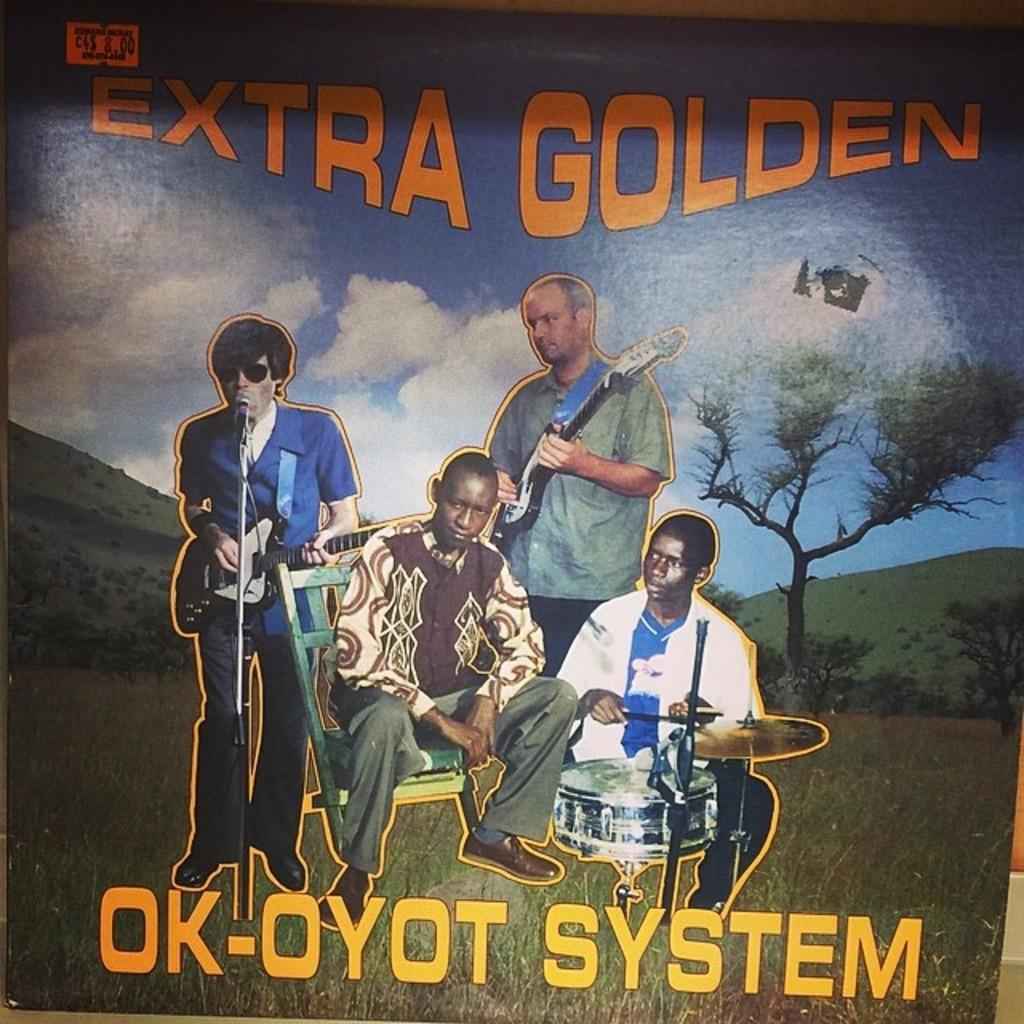<image>
Provide a brief description of the given image. Men are on an album cover for Era Golden. 